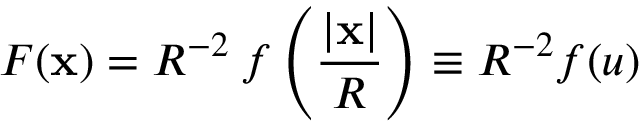Convert formula to latex. <formula><loc_0><loc_0><loc_500><loc_500>F ( x ) = R ^ { - 2 } \, f \left ( { \frac { | x | } { R } } \right ) \equiv R ^ { - 2 } f ( u )</formula> 